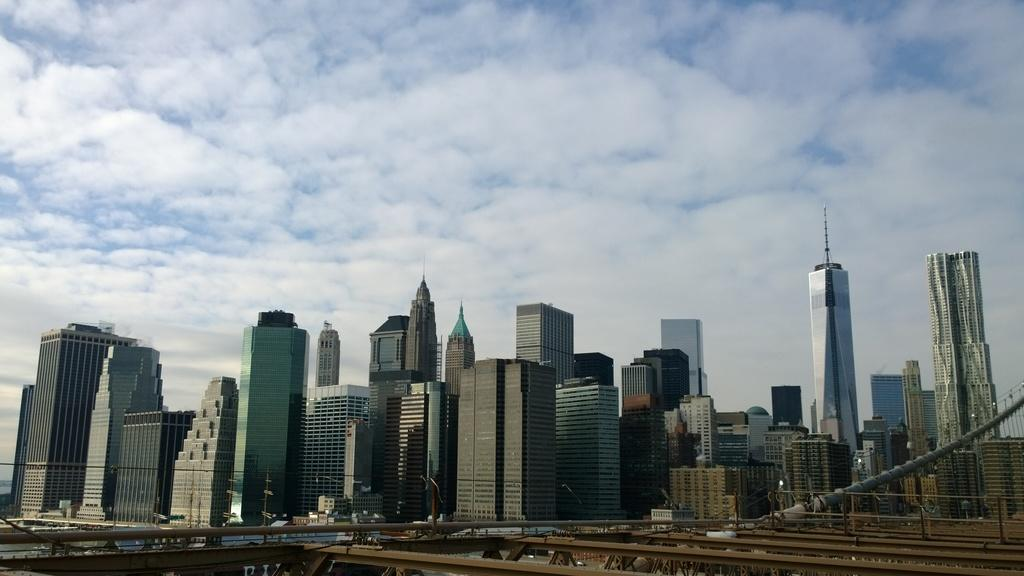What type of structures can be seen in the image? There are buildings in the image. What is the condition of the sky in the image? The sky is clouded in the image. Can you see any worms crawling on the buildings in the image? There are no worms visible in the image; it features buildings and a clouded sky. What type of club might be associated with the buildings in the image? There is no information about any clubs in the image; it only shows buildings and a clouded sky. 